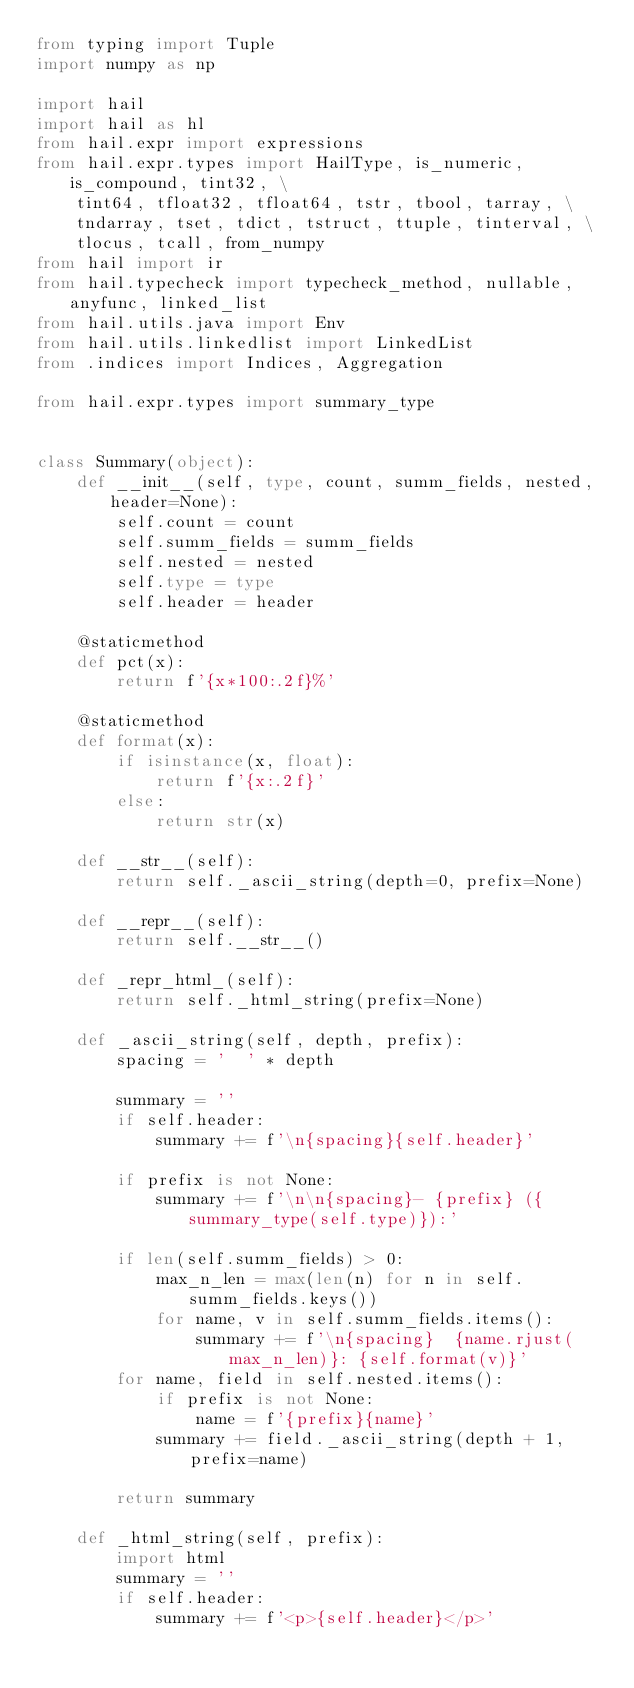Convert code to text. <code><loc_0><loc_0><loc_500><loc_500><_Python_>from typing import Tuple
import numpy as np

import hail
import hail as hl
from hail.expr import expressions
from hail.expr.types import HailType, is_numeric, is_compound, tint32, \
    tint64, tfloat32, tfloat64, tstr, tbool, tarray, \
    tndarray, tset, tdict, tstruct, ttuple, tinterval, \
    tlocus, tcall, from_numpy
from hail import ir
from hail.typecheck import typecheck_method, nullable, anyfunc, linked_list
from hail.utils.java import Env
from hail.utils.linkedlist import LinkedList
from .indices import Indices, Aggregation

from hail.expr.types import summary_type


class Summary(object):
    def __init__(self, type, count, summ_fields, nested, header=None):
        self.count = count
        self.summ_fields = summ_fields
        self.nested = nested
        self.type = type
        self.header = header

    @staticmethod
    def pct(x):
        return f'{x*100:.2f}%'

    @staticmethod
    def format(x):
        if isinstance(x, float):
            return f'{x:.2f}'
        else:
            return str(x)

    def __str__(self):
        return self._ascii_string(depth=0, prefix=None)

    def __repr__(self):
        return self.__str__()

    def _repr_html_(self):
        return self._html_string(prefix=None)

    def _ascii_string(self, depth, prefix):
        spacing = '  ' * depth

        summary = ''
        if self.header:
            summary += f'\n{spacing}{self.header}'

        if prefix is not None:
            summary += f'\n\n{spacing}- {prefix} ({summary_type(self.type)}):'

        if len(self.summ_fields) > 0:
            max_n_len = max(len(n) for n in self.summ_fields.keys())
            for name, v in self.summ_fields.items():
                summary += f'\n{spacing}  {name.rjust(max_n_len)}: {self.format(v)}'
        for name, field in self.nested.items():
            if prefix is not None:
                name = f'{prefix}{name}'
            summary += field._ascii_string(depth + 1, prefix=name)

        return summary

    def _html_string(self, prefix):
        import html
        summary = ''
        if self.header:
            summary += f'<p>{self.header}</p>'</code> 